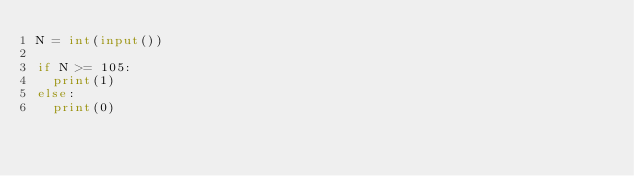Convert code to text. <code><loc_0><loc_0><loc_500><loc_500><_Python_>N = int(input())

if N >= 105:
  print(1)
else:
  print(0)</code> 